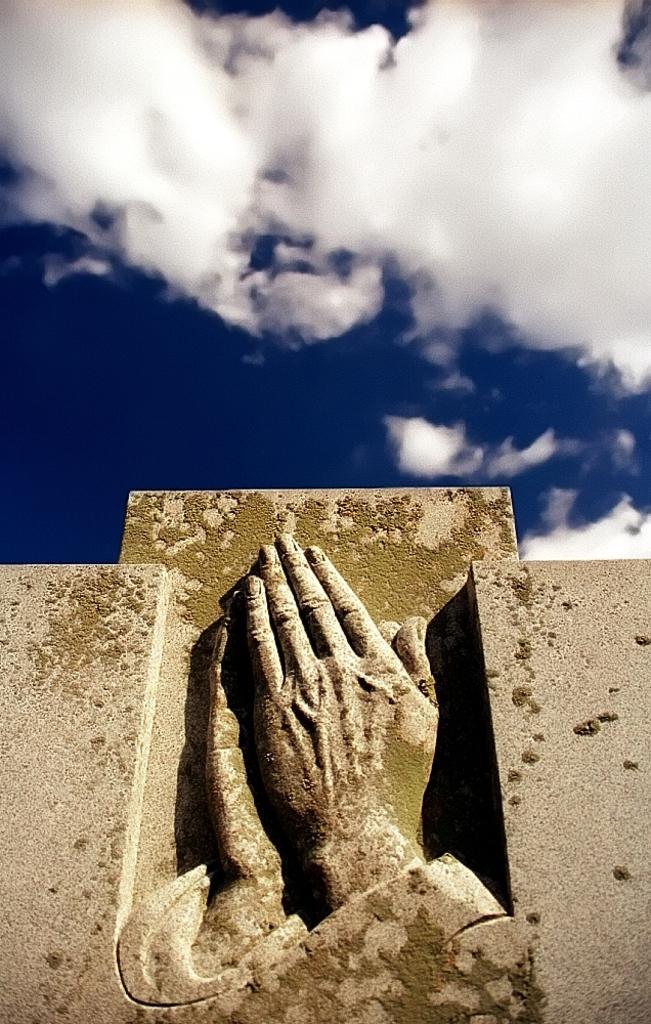Describe this image in one or two sentences. In this image at the bottom there is a sculpture and a wall, at the top of the image the sky. 